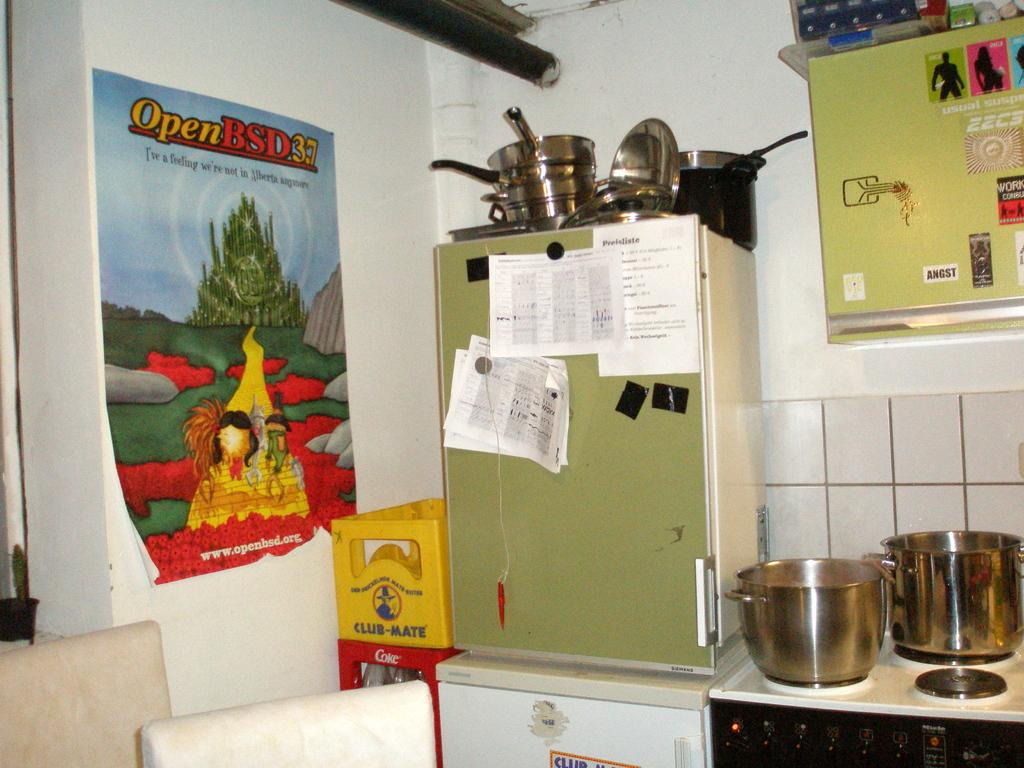Provide a one-sentence caption for the provided image. A kitchen with a poster of OpenBSD3.7 on the wall. 